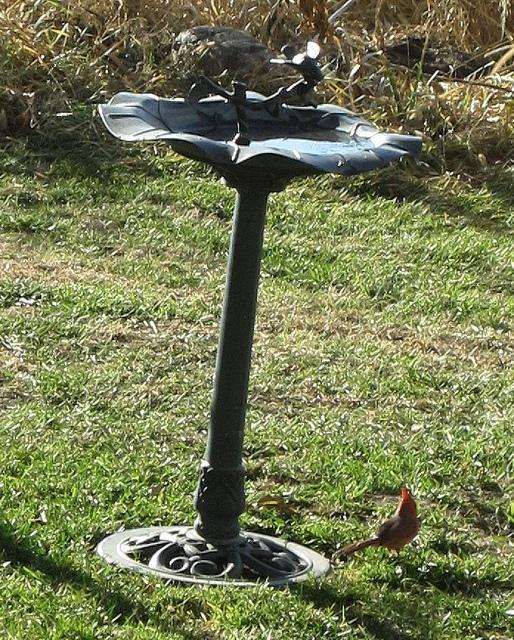How many birds are there?
Give a very brief answer. 2. 